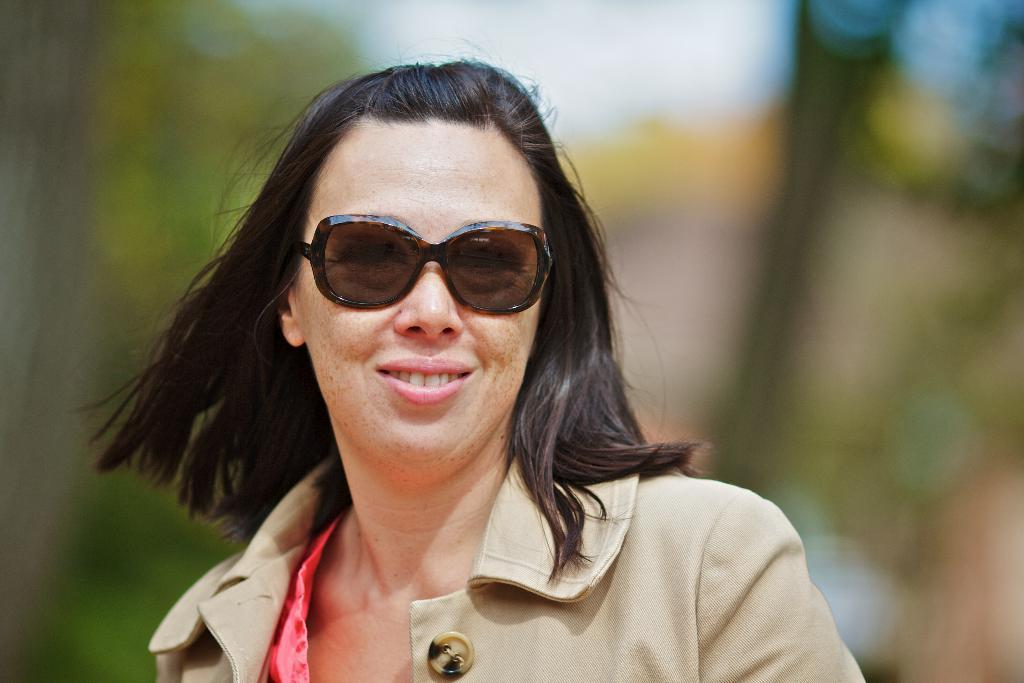Who is the main subject in the image? There is a woman in the center of the image. What letters are being smashed by the woman in the image? A: There are no letters or any smashing activity present in the image; it features a woman in the center. 